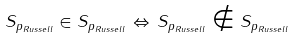Convert formula to latex. <formula><loc_0><loc_0><loc_500><loc_500>S _ { p _ { R u s s e l l } } \in S _ { p _ { R u s s e l l } } \, \Leftrightarrow \, S _ { p _ { R u s s e l l } } \notin S _ { p _ { R u s s e l l } }</formula> 